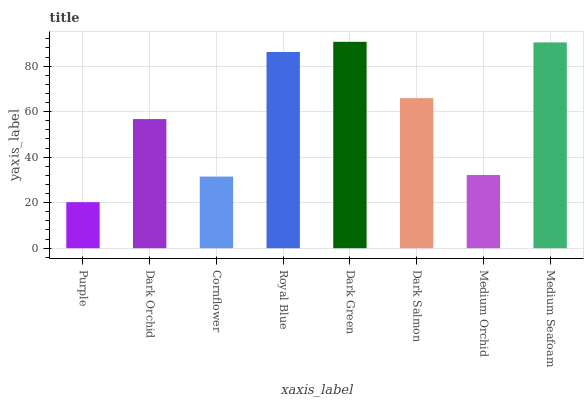Is Dark Orchid the minimum?
Answer yes or no. No. Is Dark Orchid the maximum?
Answer yes or no. No. Is Dark Orchid greater than Purple?
Answer yes or no. Yes. Is Purple less than Dark Orchid?
Answer yes or no. Yes. Is Purple greater than Dark Orchid?
Answer yes or no. No. Is Dark Orchid less than Purple?
Answer yes or no. No. Is Dark Salmon the high median?
Answer yes or no. Yes. Is Dark Orchid the low median?
Answer yes or no. Yes. Is Royal Blue the high median?
Answer yes or no. No. Is Royal Blue the low median?
Answer yes or no. No. 